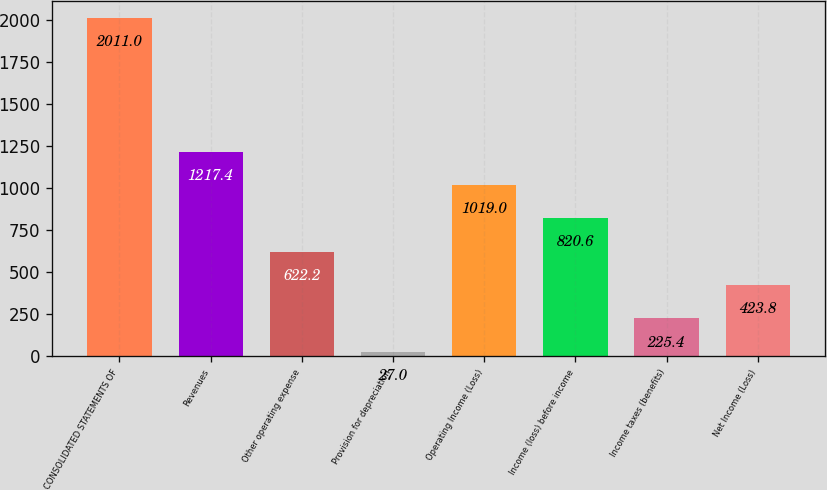<chart> <loc_0><loc_0><loc_500><loc_500><bar_chart><fcel>CONSOLIDATED STATEMENTS OF<fcel>Revenues<fcel>Other operating expense<fcel>Provision for depreciation<fcel>Operating Income (Loss)<fcel>Income (loss) before income<fcel>Income taxes (benefits)<fcel>Net Income (Loss)<nl><fcel>2011<fcel>1217.4<fcel>622.2<fcel>27<fcel>1019<fcel>820.6<fcel>225.4<fcel>423.8<nl></chart> 